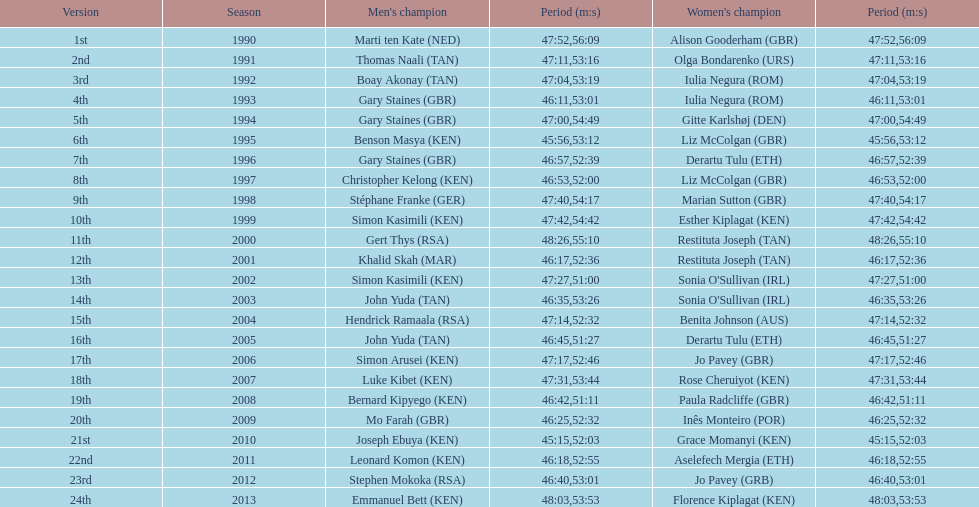What is the difference in finishing times for the men's and women's bupa great south run finish for 2013? 5:50. 